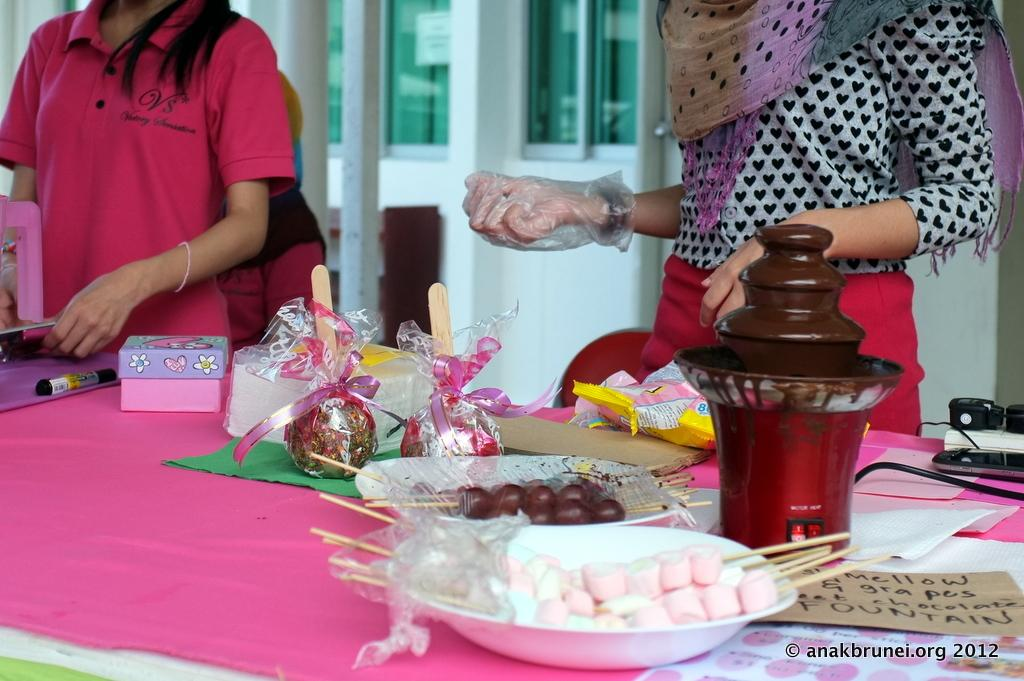What is the main subject of the image? There is a man standing in the image. What can be seen in the background of the image? There is a table in the image. What is on the table? There is food, gifts, and a chocolate fountain on the table. What type of acoustics can be heard in the image? There is no information about the acoustics in the image, as it only shows a man standing and a table with food, gifts, and a chocolate fountain. --- Facts: 1. There is a car in the image. 2. The car is red. 3. The car has four wheels. 4. There is a road in the image. 5. The road is paved. Absurd Topics: ocean, dance, bird Conversation: What is the main subject of the image? There is a car in the image. What color is the car? The car is red. How many wheels does the car have? The car has four wheels. What is the surface of the road in the image? The road is paved. Reasoning: Let's think step by step in order to produce the conversation. We start by identifying the main subject of the image, which is the car. Then, we describe the color and number of wheels of the car. Finally, we mention the surface of the road, which is paved. Each question is designed to elicit a specific detail about the image that is known from the provided facts. Absurd Question/Answer: Can you see any birds flying over the ocean in the image? There is no ocean or birds present in the image; it only shows a red car with four wheels and a paved road. 